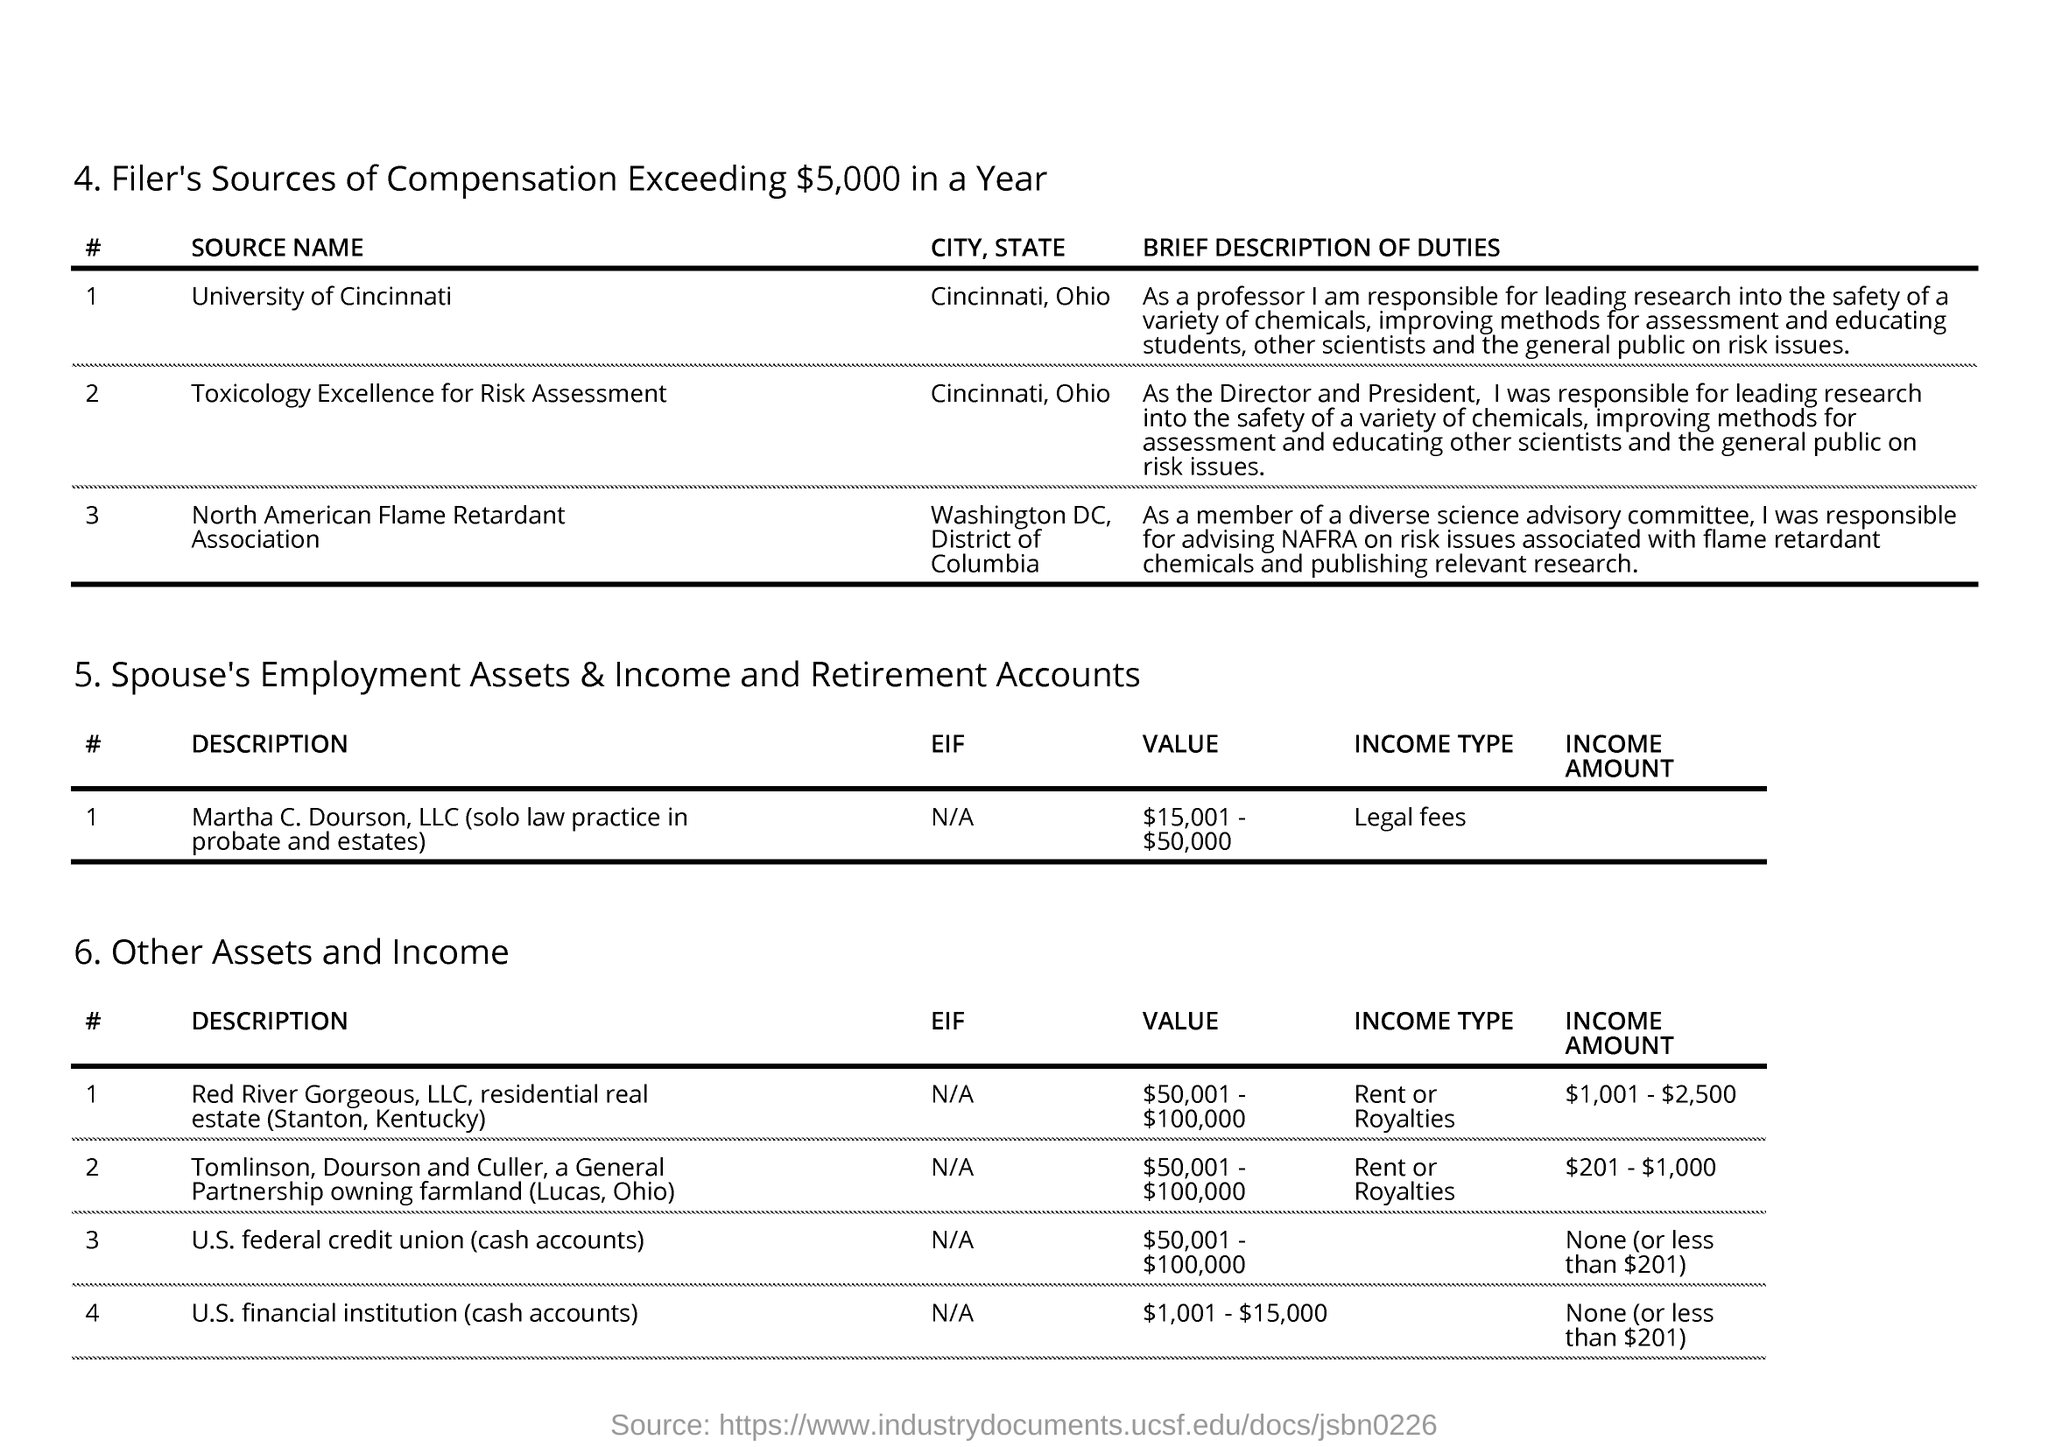Identify some key points in this picture. The Director and President of the organization were responsible for educating other scientists on risk issues. Red River Gorgeous, LLC's income type is either rent or royalties. Martha C. Dourson, LLC generates income primarily from legal fees. The value listed for Tomlinson, Dourson and Culler is between $50,001 and $100,000. 